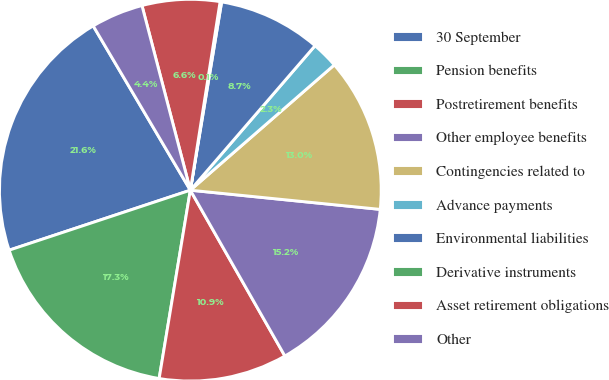<chart> <loc_0><loc_0><loc_500><loc_500><pie_chart><fcel>30 September<fcel>Pension benefits<fcel>Postretirement benefits<fcel>Other employee benefits<fcel>Contingencies related to<fcel>Advance payments<fcel>Environmental liabilities<fcel>Derivative instruments<fcel>Asset retirement obligations<fcel>Other<nl><fcel>21.59%<fcel>17.3%<fcel>10.86%<fcel>15.15%<fcel>13.0%<fcel>2.27%<fcel>8.71%<fcel>0.13%<fcel>6.57%<fcel>4.42%<nl></chart> 